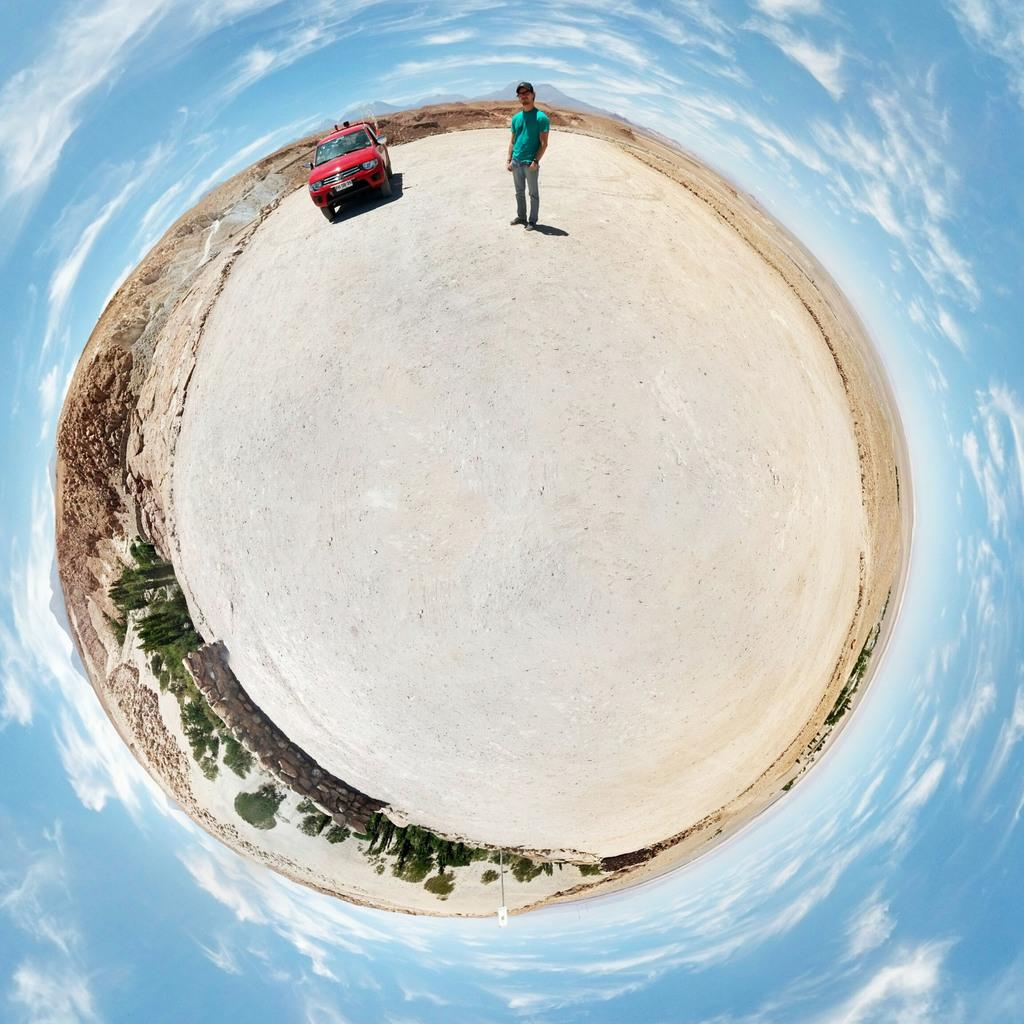What is the main subject of the image? There is a person standing in the image. Can you describe the person's attire? The person is wearing clothes. What else can be seen in the image besides the person? There is a vehicle, sand, a wall, a stone wall, trees, and the sky in the image. How would you describe the sky in the image? The sky is cloudy and pale blue. What type of box is being used to store the pests in the image? There is no box or pests present in the image. Is there a birthday celebration happening in the image? There is no indication of a birthday celebration in the image. 